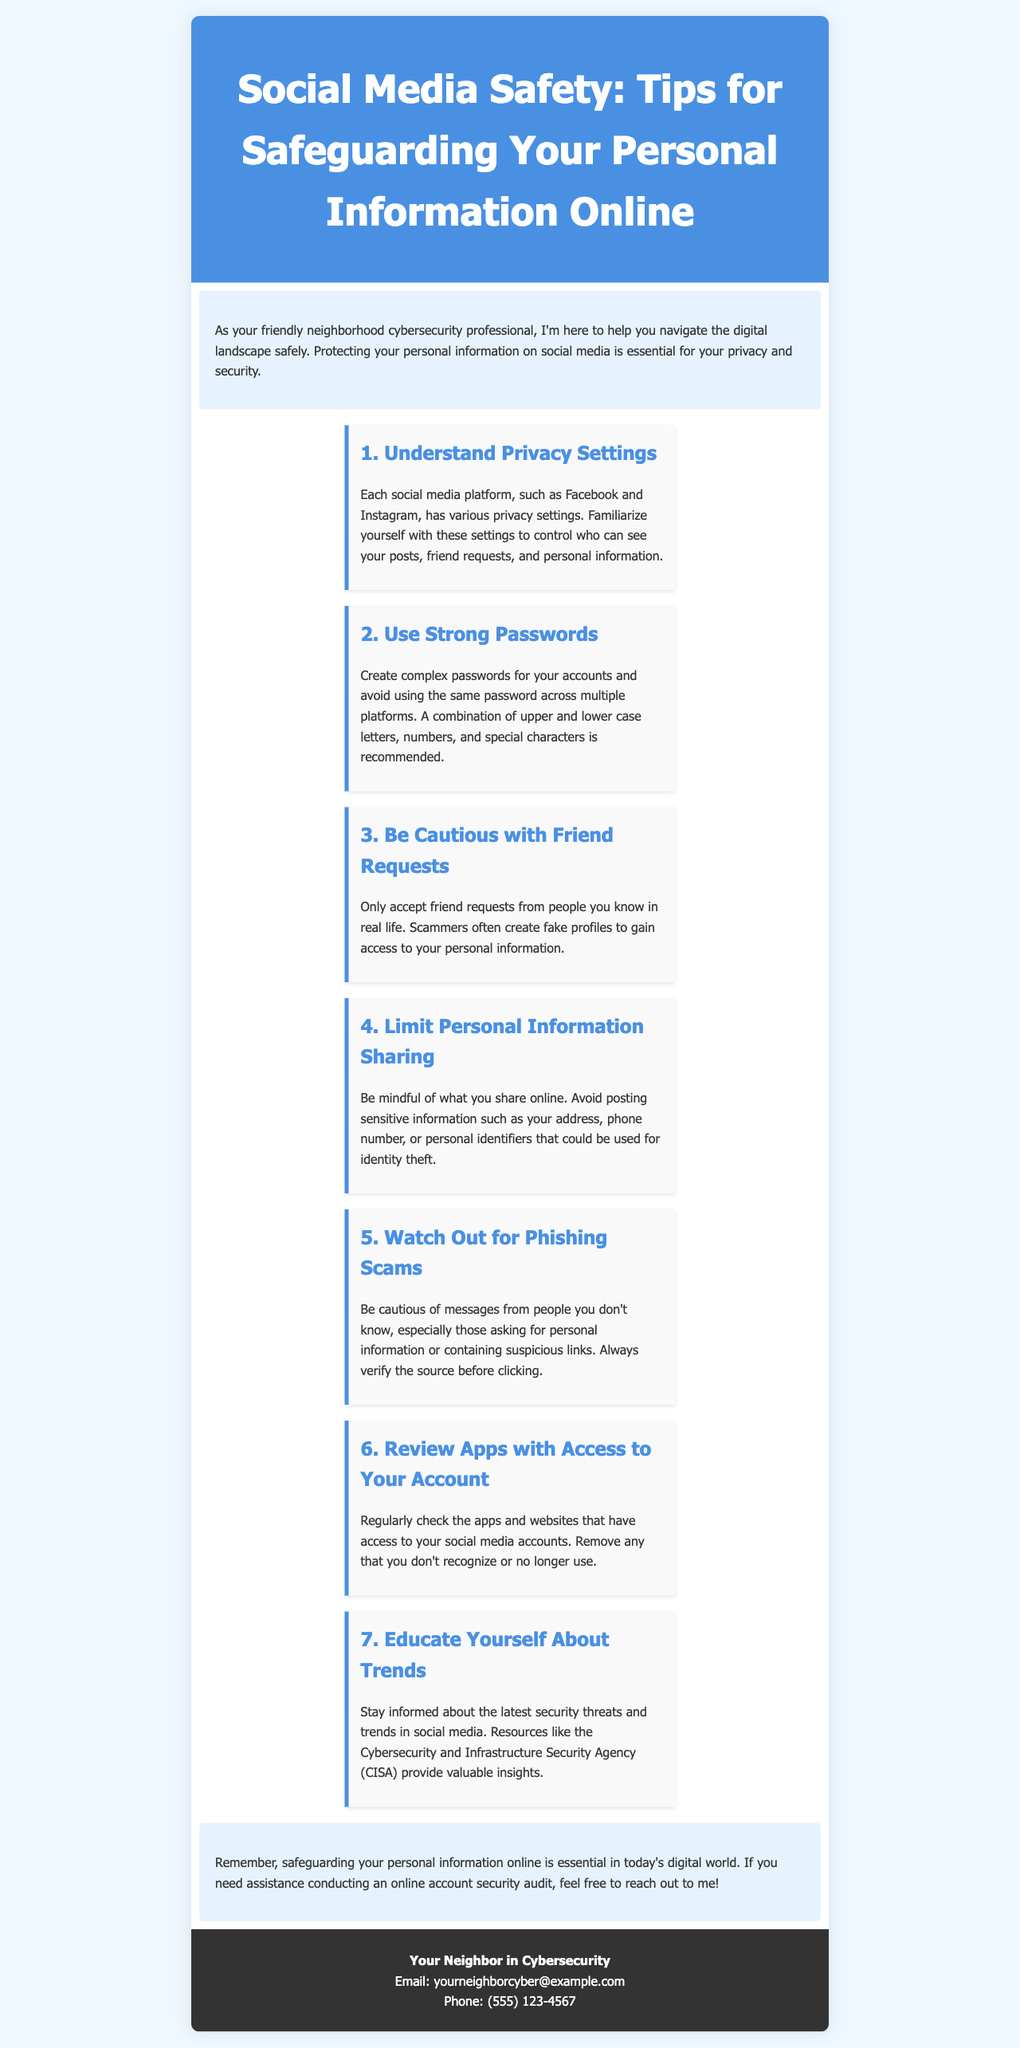What is the main title of the brochure? The title is prominently displayed at the top of the document, summarizing the content's theme.
Answer: Social Media Safety: Tips for Safeguarding Your Personal Information Online Who is offering assistance with online account security? The contact section identifies the person providing help, emphasizing their role in cybersecurity within the community.
Answer: Your Neighbor in Cybersecurity What should you use to create passwords? The document specifically mentions the characteristics recommended for passwords.
Answer: Strong passwords How many tips are provided in the brochure? The number of tips is indicated by the listed sections within the tips area.
Answer: Seven What does the second tip emphasize? The second tip focuses on a specific action users should take regarding their account security.
Answer: Use Strong Passwords What type of information should you be cautious about sharing? The document advises against sharing certain types of sensitive information for safety.
Answer: Personal information What organization provides insights on security trends? The document mentions a specific organization that offers resources related to cybersecurity trends.
Answer: Cybersecurity and Infrastructure Security Agency (CISA) 